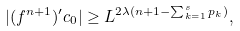<formula> <loc_0><loc_0><loc_500><loc_500>| ( f ^ { n + 1 } ) ^ { \prime } c _ { 0 } | \geq L ^ { 2 \lambda ( n + 1 - \sum _ { k = 1 } ^ { s } p _ { k } ) } ,</formula> 